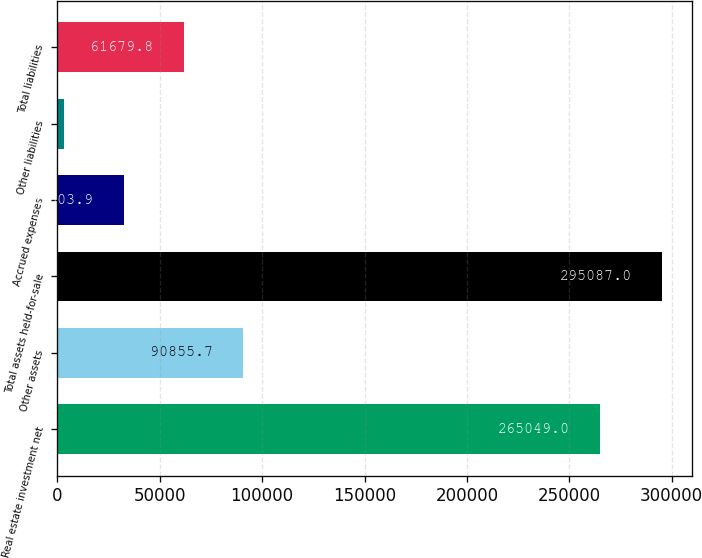Convert chart. <chart><loc_0><loc_0><loc_500><loc_500><bar_chart><fcel>Real estate investment net<fcel>Other assets<fcel>Total assets held-for-sale<fcel>Accrued expenses<fcel>Other liabilities<fcel>Total liabilities<nl><fcel>265049<fcel>90855.7<fcel>295087<fcel>32503.9<fcel>3328<fcel>61679.8<nl></chart> 